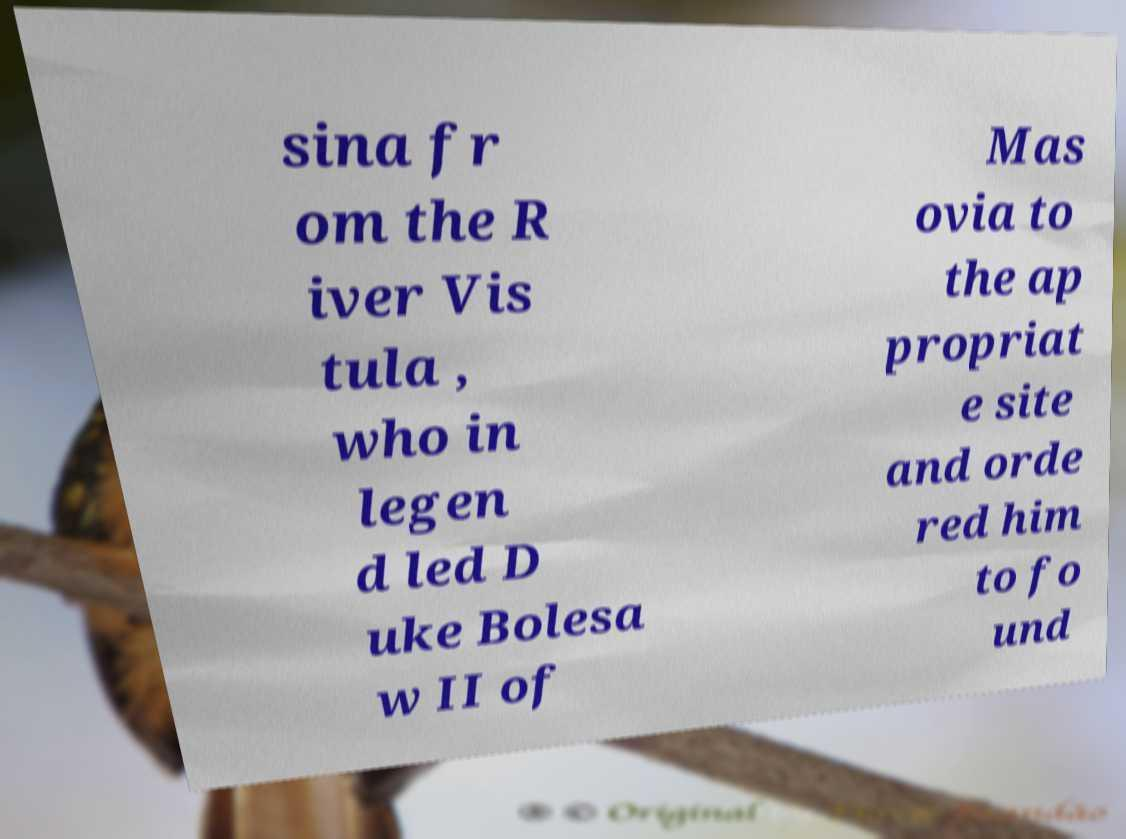Could you extract and type out the text from this image? sina fr om the R iver Vis tula , who in legen d led D uke Bolesa w II of Mas ovia to the ap propriat e site and orde red him to fo und 